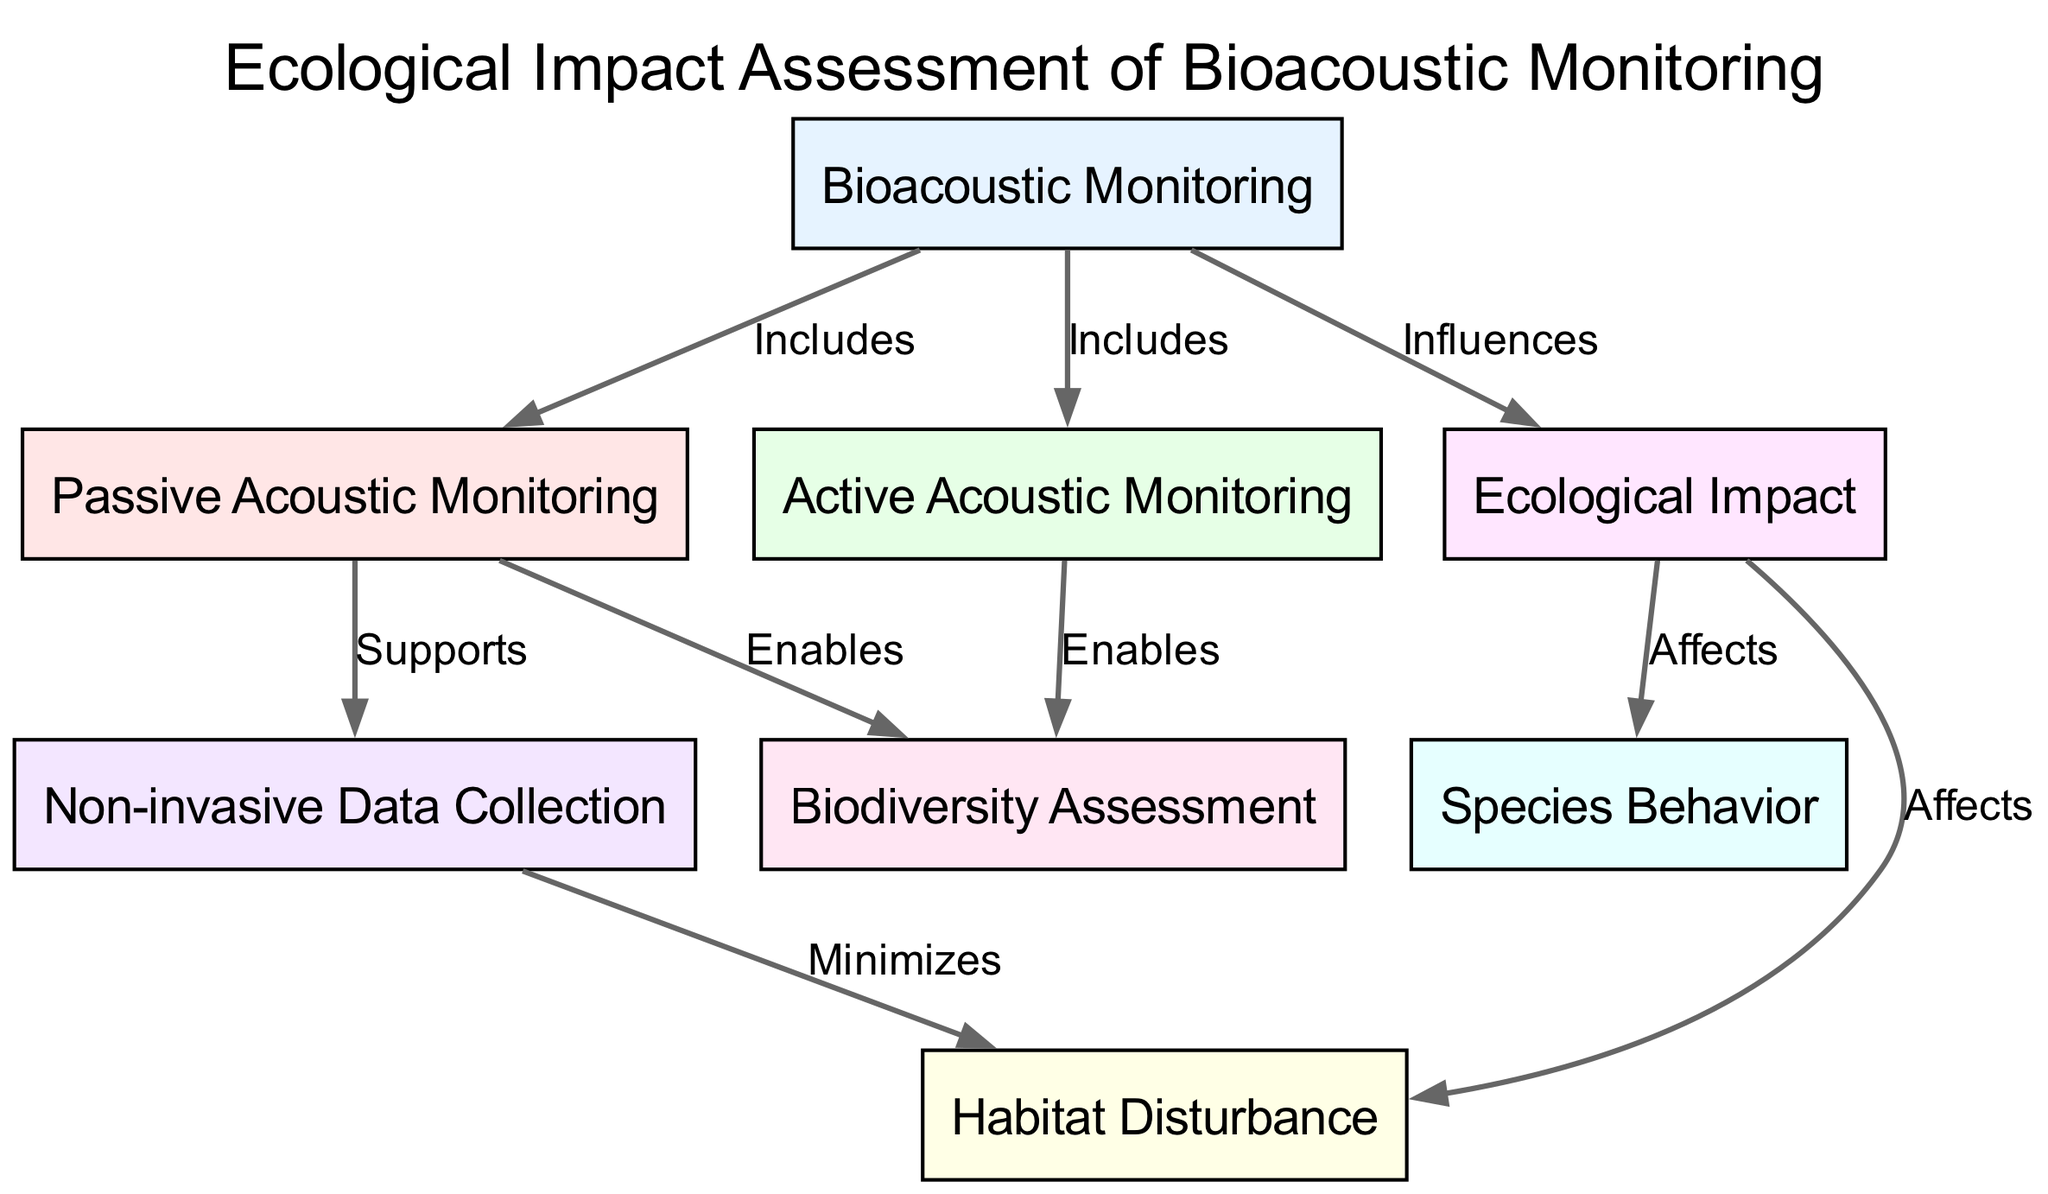What are the two types of Acoustic Monitoring included in Bioacoustic Monitoring? Referring to the diagram, Bioacoustic Monitoring has edges that include Passive Acoustic Monitoring and Active Acoustic Monitoring.
Answer: Passive Acoustic Monitoring, Active Acoustic Monitoring How many nodes are present in the diagram? Counting all distinct entities in the diagram, there are a total of eight nodes.
Answer: 8 What does Passive Acoustic Monitoring enable? According to the diagram, there is an edge from Passive Acoustic Monitoring to Biodiversity Assessment indicating it enables this process.
Answer: Biodiversity Assessment What is one effect of Ecological Impact mentioned in the diagram? The diagram shows that Ecological Impact affects both Habitat Disturbance and Species Behavior, indicating these as effects of Ecological Impact.
Answer: Habitat Disturbance, Species Behavior How does Non-invasive Data Collection impact Habitat Disturbance? The diagram states that Non-invasive Data Collection minimizes Habitat Disturbance, showing a directly supportive relationship.
Answer: Minimizes What influences Ecological Impact? The relationship diagram indicates that Bioacoustic Monitoring influences Ecological Impact directly. Thus, it is the influencing entity for the Ecological Impact.
Answer: Bioacoustic Monitoring Which Acoustic Monitoring type supports Non-invasive Data Collection? In the diagram, Passive Acoustic Monitoring supports Non-invasive Data Collection, as depicted by the corresponding edge.
Answer: Passive Acoustic Monitoring What type of monitoring approach is related to both Biodiversity Assessment and Non-invasive Data Collection? Both Passive and Active Acoustic Monitoring enable Biodiversity Assessment and support Non-invasive Data Collection, establishing a key connection among these nodes.
Answer: Passive Acoustic Monitoring, Active Acoustic Monitoring 